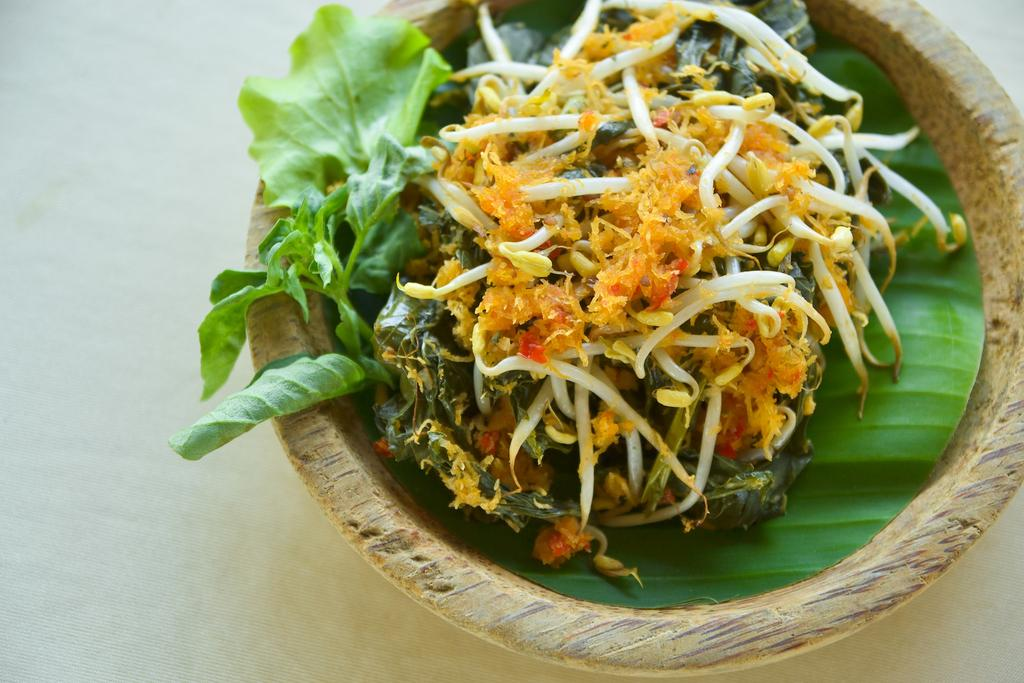What type of food is present in the image? There is food in the image, including vegetable leaves. What type of dish is the food placed in? There is a bowl in the image. On what surface is the bowl placed? The bowl is on a white surface. How many yams are visible in the image? There is no yam present in the image. What type of cracker is placed on the white surface in the image? There is no cracker present in the image. 